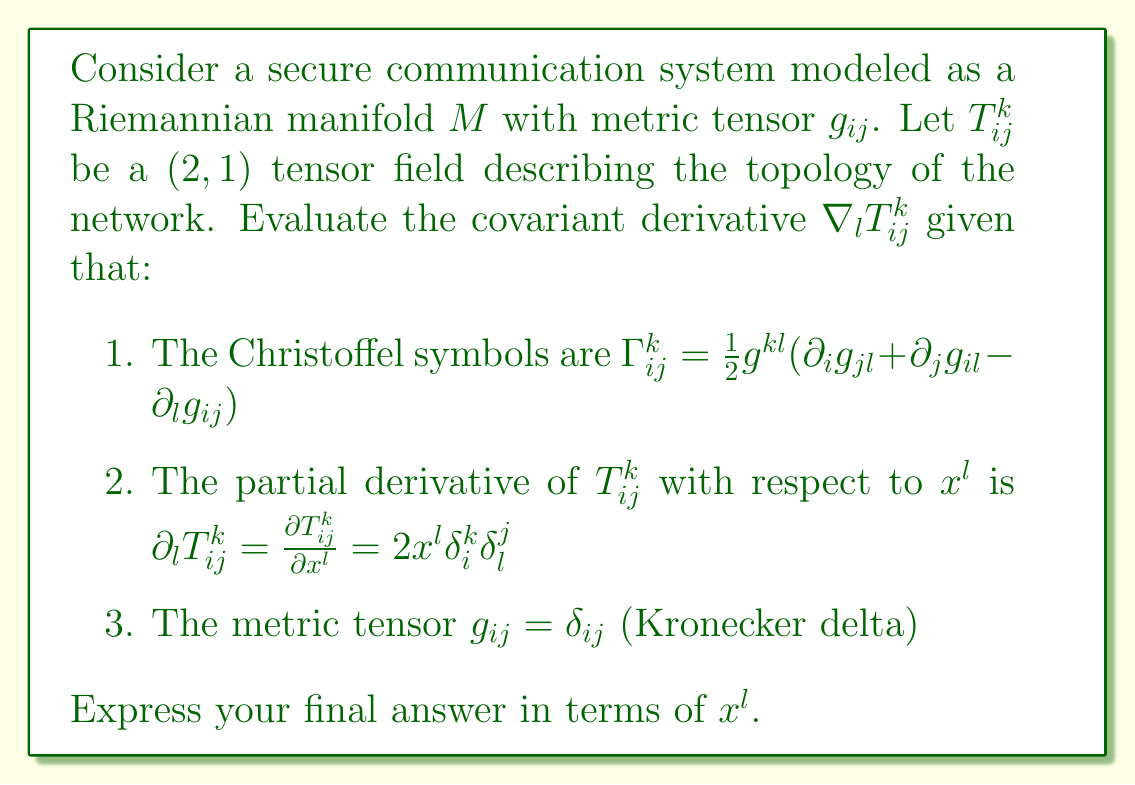Can you solve this math problem? To evaluate the covariant derivative of the tensor $T^{k}_{ij}$, we use the formula:

$$\nabla_l T^{k}_{ij} = \partial_l T^{k}_{ij} + \Gamma^k_{lm}T^{m}_{ij} - \Gamma^m_{li}T^{k}_{mj} - \Gamma^m_{lj}T^{k}_{im}$$

Let's evaluate each term:

1. $\partial_l T^{k}_{ij}$: Given in the problem as $2x^l \delta^k_i \delta^j_l$

2. $\Gamma^k_{lm}$: Since $g_{ij} = \delta_{ij}$, we have $g^{kl} = \delta^{kl}$. Also, $\partial_i g_{jl} = \partial_j g_{il} = \partial_l g_{ij} = 0$. Therefore:
   $$\Gamma^k_{lm} = \frac{1}{2}\delta^{kl}(0 + 0 - 0) = 0$$

3. $\Gamma^m_{li}$ and $\Gamma^m_{lj}$: Similarly, these are also zero.

Substituting these into the covariant derivative formula:

$$\nabla_l T^{k}_{ij} = 2x^l \delta^k_i \delta^j_l + 0 - 0 - 0 = 2x^l \delta^k_i \delta^j_l$$

This is our final expression for the covariant derivative.
Answer: $\nabla_l T^{k}_{ij} = 2x^l \delta^k_i \delta^j_l$ 